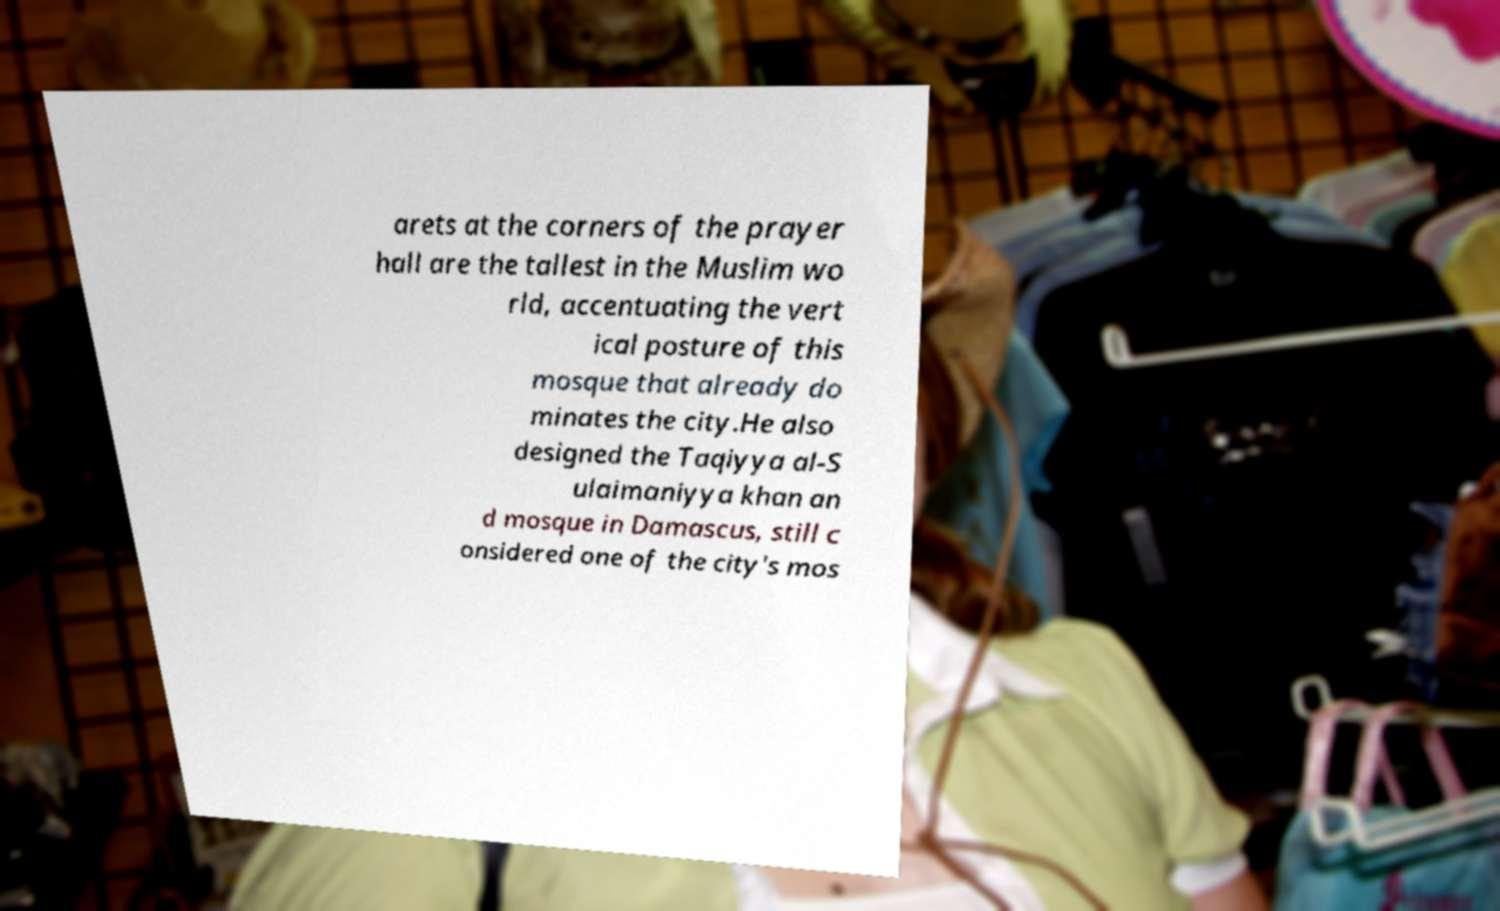Please read and relay the text visible in this image. What does it say? arets at the corners of the prayer hall are the tallest in the Muslim wo rld, accentuating the vert ical posture of this mosque that already do minates the city.He also designed the Taqiyya al-S ulaimaniyya khan an d mosque in Damascus, still c onsidered one of the city's mos 